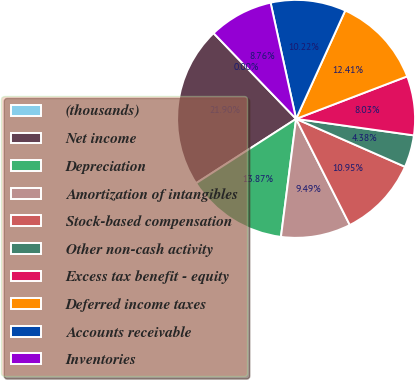Convert chart to OTSL. <chart><loc_0><loc_0><loc_500><loc_500><pie_chart><fcel>(thousands)<fcel>Net income<fcel>Depreciation<fcel>Amortization of intangibles<fcel>Stock-based compensation<fcel>Other non-cash activity<fcel>Excess tax benefit - equity<fcel>Deferred income taxes<fcel>Accounts receivable<fcel>Inventories<nl><fcel>0.0%<fcel>21.9%<fcel>13.87%<fcel>9.49%<fcel>10.95%<fcel>4.38%<fcel>8.03%<fcel>12.41%<fcel>10.22%<fcel>8.76%<nl></chart> 